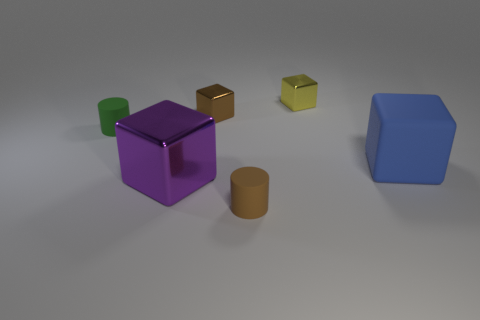Subtract all brown blocks. How many blocks are left? 3 Subtract all yellow cubes. How many cubes are left? 3 Add 4 green objects. How many objects exist? 10 Subtract 3 cubes. How many cubes are left? 1 Subtract all yellow cylinders. Subtract all cyan spheres. How many cylinders are left? 2 Subtract all red blocks. How many green cylinders are left? 1 Subtract all gray cubes. Subtract all large matte cubes. How many objects are left? 5 Add 5 small brown shiny objects. How many small brown shiny objects are left? 6 Add 6 cylinders. How many cylinders exist? 8 Subtract 1 green cylinders. How many objects are left? 5 